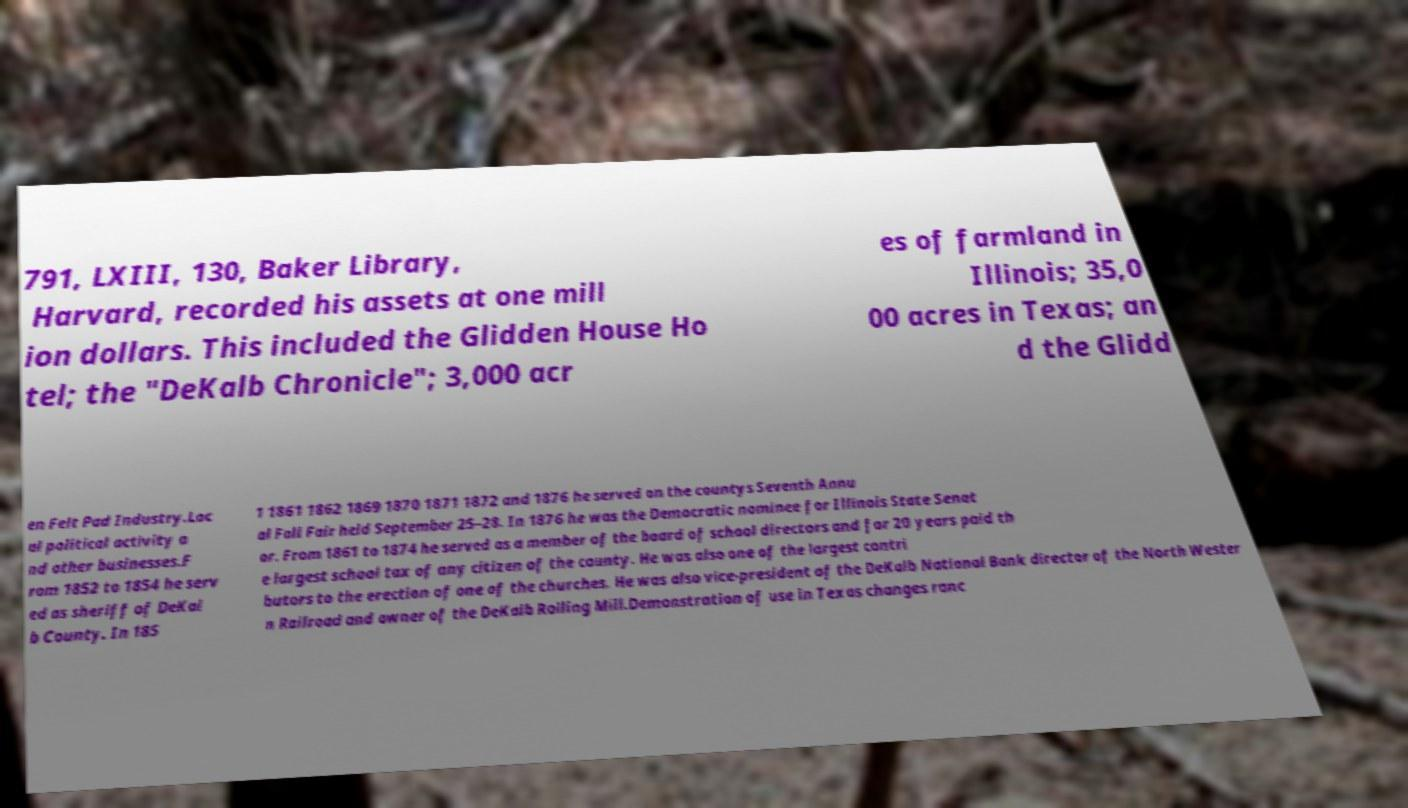Please read and relay the text visible in this image. What does it say? 791, LXIII, 130, Baker Library, Harvard, recorded his assets at one mill ion dollars. This included the Glidden House Ho tel; the "DeKalb Chronicle"; 3,000 acr es of farmland in Illinois; 35,0 00 acres in Texas; an d the Glidd en Felt Pad Industry.Loc al political activity a nd other businesses.F rom 1852 to 1854 he serv ed as sheriff of DeKal b County. In 185 1 1861 1862 1869 1870 1871 1872 and 1876 he served on the countys Seventh Annu al Fall Fair held September 25–28. In 1876 he was the Democratic nominee for Illinois State Senat or. From 1861 to 1874 he served as a member of the board of school directors and for 20 years paid th e largest school tax of any citizen of the county. He was also one of the largest contri butors to the erection of one of the churches. He was also vice-president of the DeKalb National Bank director of the North Wester n Railroad and owner of the DeKalb Rolling Mill.Demonstration of use in Texas changes ranc 